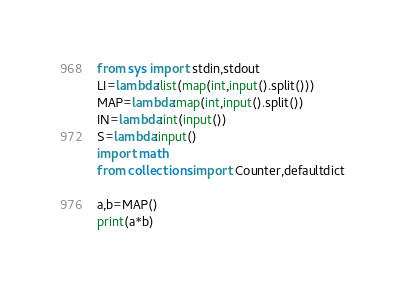Convert code to text. <code><loc_0><loc_0><loc_500><loc_500><_Python_>from sys import stdin,stdout
LI=lambda:list(map(int,input().split()))
MAP=lambda:map(int,input().split())
IN=lambda:int(input())
S=lambda:input()
import math
from collections import Counter,defaultdict

a,b=MAP()
print(a*b)
</code> 